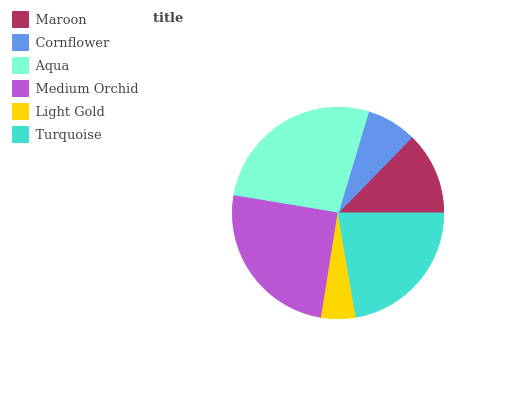Is Light Gold the minimum?
Answer yes or no. Yes. Is Aqua the maximum?
Answer yes or no. Yes. Is Cornflower the minimum?
Answer yes or no. No. Is Cornflower the maximum?
Answer yes or no. No. Is Maroon greater than Cornflower?
Answer yes or no. Yes. Is Cornflower less than Maroon?
Answer yes or no. Yes. Is Cornflower greater than Maroon?
Answer yes or no. No. Is Maroon less than Cornflower?
Answer yes or no. No. Is Turquoise the high median?
Answer yes or no. Yes. Is Maroon the low median?
Answer yes or no. Yes. Is Cornflower the high median?
Answer yes or no. No. Is Turquoise the low median?
Answer yes or no. No. 